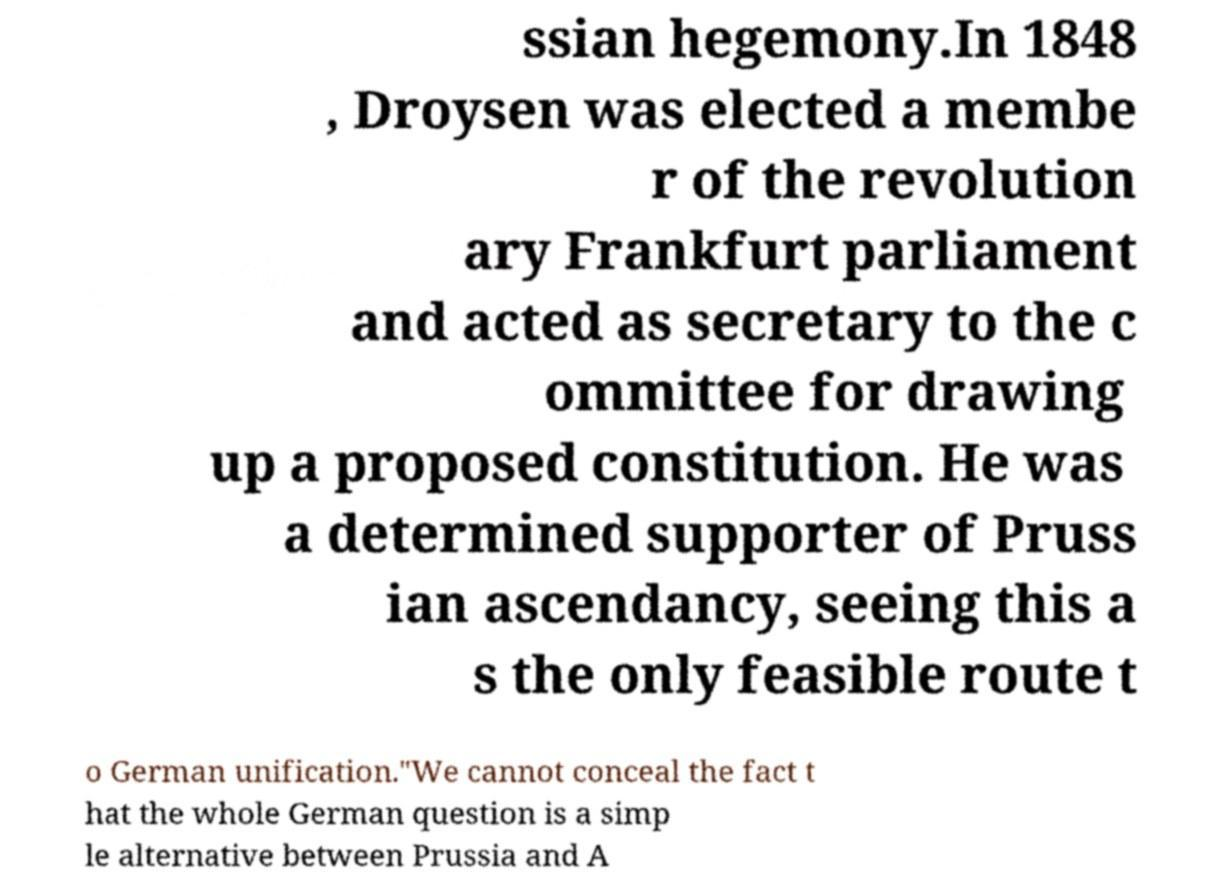Can you read and provide the text displayed in the image?This photo seems to have some interesting text. Can you extract and type it out for me? ssian hegemony.In 1848 , Droysen was elected a membe r of the revolution ary Frankfurt parliament and acted as secretary to the c ommittee for drawing up a proposed constitution. He was a determined supporter of Pruss ian ascendancy, seeing this a s the only feasible route t o German unification."We cannot conceal the fact t hat the whole German question is a simp le alternative between Prussia and A 